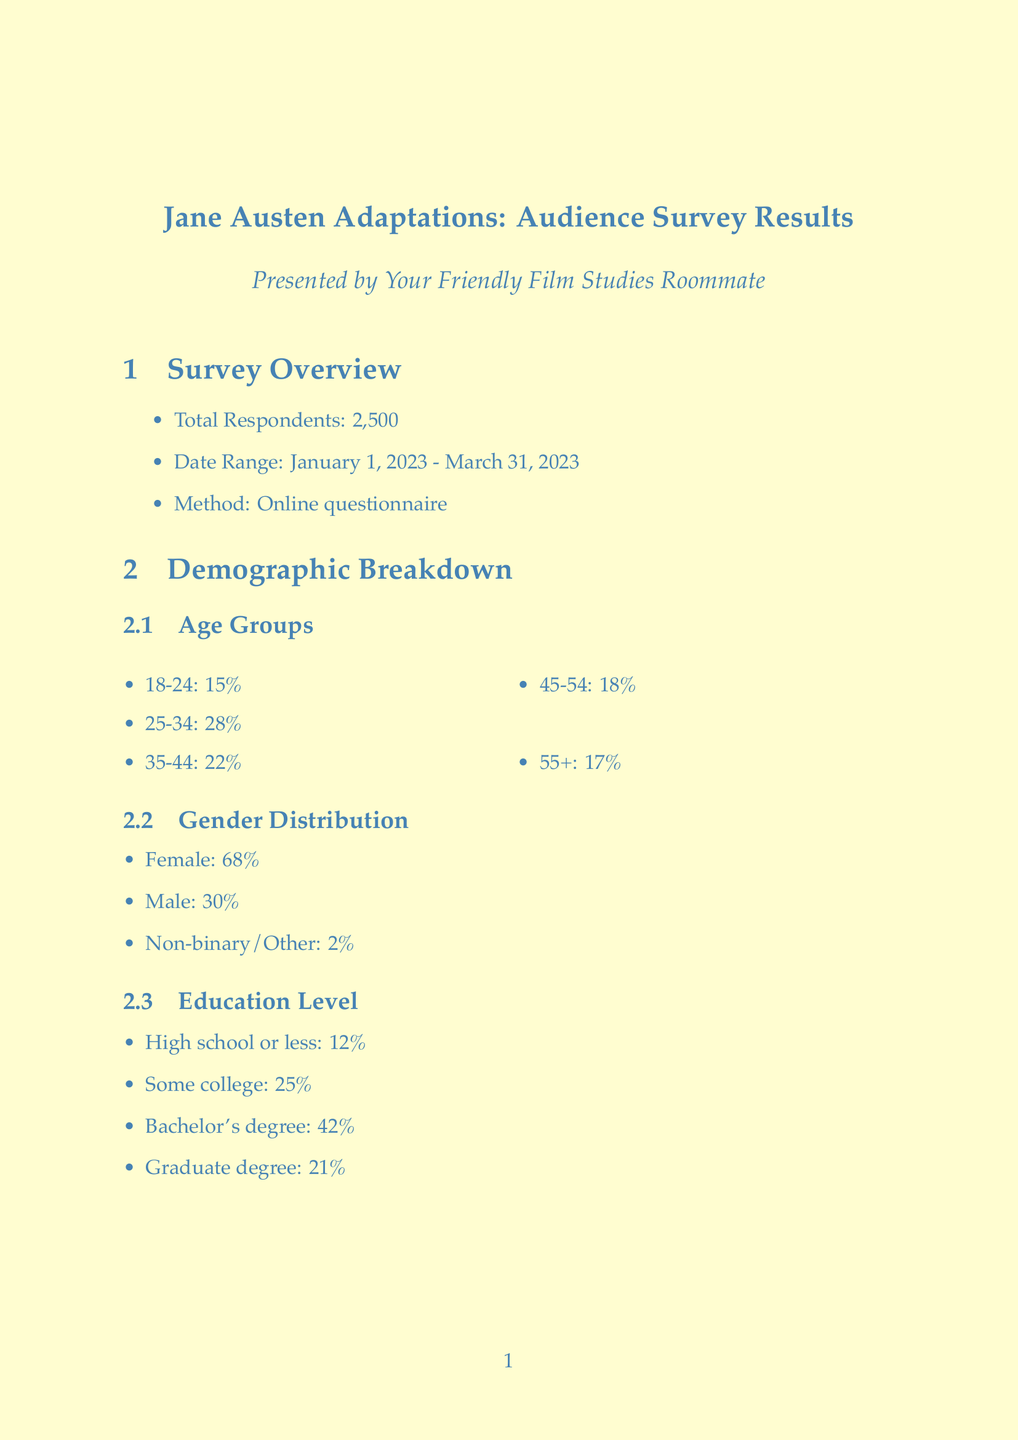What was the total number of respondents? The total number of respondents is provided in the survey overview section of the document.
Answer: 2500 What percentage of respondents prefer traditional or period-accurate settings? This percentage is mentioned in the adaptation preferences section, under setting preferences.
Answer: 68% Which adaptation had the highest viewership? The popular adaptations section lists viewership percentages, and the one with the highest is indicated.
Answer: Pride and Prejudice (2005) What is the most preferred viewing platform? The preferred platforms section indicates the percentage of respondents that prefer each platform, with the highest listed first.
Answer: Netflix What percentage of respondents watch adaptations quarterly? The viewing frequency section details the various times respondents watch, and this specific frequency is included.
Answer: 30% What impact do adaptations have on viewers' reading habits? The influence on viewers' behavior section describes the change in reading habits, focusing on the reported impacts.
Answer: Increased interest in reading Austen novels What percentage of viewers reported highly enjoying the adaptations? This information is found in the roommate feedback section, under enjoyment level.
Answer: 60% What adaptations were requested by viewers? The requested adaptations are listed in the roommate feedback section, specifically detailing which adaptations were mentioned.
Answer: Pride and Prejudice and Zombies (2016), Bridgerton, Clueless, The Lizzie Bennet Diaries What percentage of respondents preferred to watch during weekday evenings? The preferred viewing time section outlines timing preferences, indicating the specific percentage for weekday evenings.
Answer: 45% 